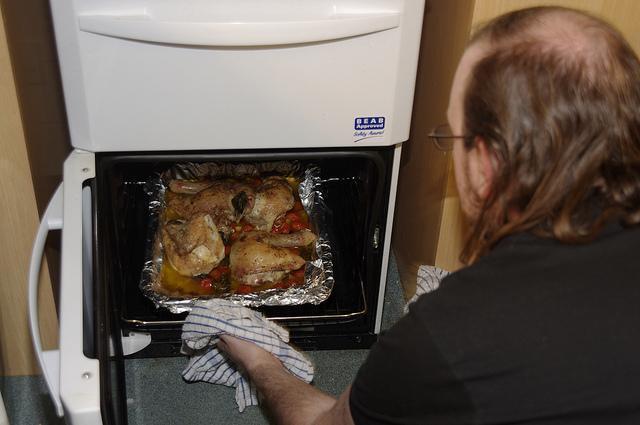How many boats are under these gray clouds?
Give a very brief answer. 0. 